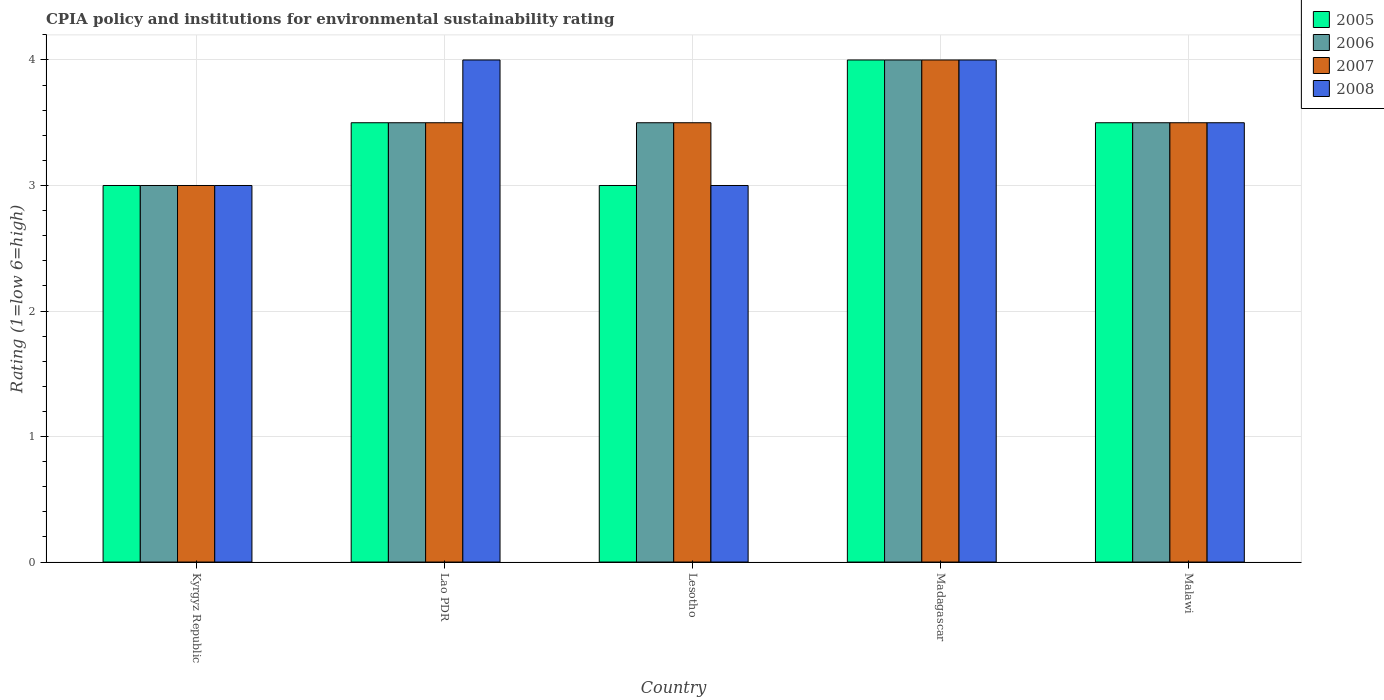How many different coloured bars are there?
Your answer should be compact. 4. How many groups of bars are there?
Your answer should be very brief. 5. Are the number of bars on each tick of the X-axis equal?
Keep it short and to the point. Yes. What is the label of the 1st group of bars from the left?
Your response must be concise. Kyrgyz Republic. Across all countries, what is the minimum CPIA rating in 2005?
Offer a terse response. 3. In which country was the CPIA rating in 2007 maximum?
Offer a terse response. Madagascar. In which country was the CPIA rating in 2007 minimum?
Provide a short and direct response. Kyrgyz Republic. What is the total CPIA rating in 2006 in the graph?
Offer a very short reply. 17.5. Is the difference between the CPIA rating in 2006 in Kyrgyz Republic and Lao PDR greater than the difference between the CPIA rating in 2005 in Kyrgyz Republic and Lao PDR?
Provide a short and direct response. No. In how many countries, is the CPIA rating in 2006 greater than the average CPIA rating in 2006 taken over all countries?
Offer a terse response. 1. Is it the case that in every country, the sum of the CPIA rating in 2006 and CPIA rating in 2008 is greater than the sum of CPIA rating in 2007 and CPIA rating in 2005?
Your answer should be very brief. No. What does the 1st bar from the left in Madagascar represents?
Give a very brief answer. 2005. What does the 1st bar from the right in Kyrgyz Republic represents?
Provide a short and direct response. 2008. Is it the case that in every country, the sum of the CPIA rating in 2007 and CPIA rating in 2008 is greater than the CPIA rating in 2006?
Offer a terse response. Yes. Are the values on the major ticks of Y-axis written in scientific E-notation?
Keep it short and to the point. No. Does the graph contain grids?
Provide a succinct answer. Yes. Where does the legend appear in the graph?
Offer a very short reply. Top right. How are the legend labels stacked?
Your answer should be compact. Vertical. What is the title of the graph?
Offer a very short reply. CPIA policy and institutions for environmental sustainability rating. Does "2012" appear as one of the legend labels in the graph?
Offer a terse response. No. What is the Rating (1=low 6=high) of 2006 in Kyrgyz Republic?
Your answer should be very brief. 3. What is the Rating (1=low 6=high) in 2007 in Kyrgyz Republic?
Your answer should be compact. 3. What is the Rating (1=low 6=high) of 2008 in Lao PDR?
Offer a terse response. 4. What is the Rating (1=low 6=high) in 2005 in Lesotho?
Offer a very short reply. 3. What is the Rating (1=low 6=high) in 2008 in Lesotho?
Offer a terse response. 3. What is the Rating (1=low 6=high) in 2006 in Madagascar?
Offer a terse response. 4. What is the Rating (1=low 6=high) in 2007 in Madagascar?
Your answer should be very brief. 4. What is the Rating (1=low 6=high) of 2008 in Madagascar?
Give a very brief answer. 4. What is the Rating (1=low 6=high) in 2006 in Malawi?
Your response must be concise. 3.5. What is the Rating (1=low 6=high) of 2007 in Malawi?
Your answer should be very brief. 3.5. Across all countries, what is the maximum Rating (1=low 6=high) of 2008?
Your answer should be very brief. 4. Across all countries, what is the minimum Rating (1=low 6=high) of 2006?
Give a very brief answer. 3. Across all countries, what is the minimum Rating (1=low 6=high) of 2008?
Offer a very short reply. 3. What is the total Rating (1=low 6=high) in 2008 in the graph?
Your answer should be very brief. 17.5. What is the difference between the Rating (1=low 6=high) of 2007 in Kyrgyz Republic and that in Lao PDR?
Offer a very short reply. -0.5. What is the difference between the Rating (1=low 6=high) in 2008 in Kyrgyz Republic and that in Lao PDR?
Keep it short and to the point. -1. What is the difference between the Rating (1=low 6=high) in 2005 in Kyrgyz Republic and that in Lesotho?
Offer a terse response. 0. What is the difference between the Rating (1=low 6=high) of 2006 in Kyrgyz Republic and that in Lesotho?
Ensure brevity in your answer.  -0.5. What is the difference between the Rating (1=low 6=high) in 2008 in Kyrgyz Republic and that in Madagascar?
Offer a terse response. -1. What is the difference between the Rating (1=low 6=high) in 2008 in Lao PDR and that in Lesotho?
Ensure brevity in your answer.  1. What is the difference between the Rating (1=low 6=high) in 2006 in Lao PDR and that in Madagascar?
Offer a very short reply. -0.5. What is the difference between the Rating (1=low 6=high) in 2007 in Lao PDR and that in Madagascar?
Provide a short and direct response. -0.5. What is the difference between the Rating (1=low 6=high) of 2008 in Lao PDR and that in Madagascar?
Your answer should be very brief. 0. What is the difference between the Rating (1=low 6=high) in 2005 in Lao PDR and that in Malawi?
Offer a terse response. 0. What is the difference between the Rating (1=low 6=high) of 2006 in Lao PDR and that in Malawi?
Provide a succinct answer. 0. What is the difference between the Rating (1=low 6=high) of 2008 in Lao PDR and that in Malawi?
Make the answer very short. 0.5. What is the difference between the Rating (1=low 6=high) in 2005 in Lesotho and that in Madagascar?
Ensure brevity in your answer.  -1. What is the difference between the Rating (1=low 6=high) of 2006 in Lesotho and that in Madagascar?
Offer a terse response. -0.5. What is the difference between the Rating (1=low 6=high) of 2008 in Lesotho and that in Madagascar?
Give a very brief answer. -1. What is the difference between the Rating (1=low 6=high) of 2007 in Lesotho and that in Malawi?
Give a very brief answer. 0. What is the difference between the Rating (1=low 6=high) in 2005 in Madagascar and that in Malawi?
Keep it short and to the point. 0.5. What is the difference between the Rating (1=low 6=high) in 2005 in Kyrgyz Republic and the Rating (1=low 6=high) in 2006 in Lao PDR?
Provide a short and direct response. -0.5. What is the difference between the Rating (1=low 6=high) of 2005 in Kyrgyz Republic and the Rating (1=low 6=high) of 2007 in Lao PDR?
Your answer should be compact. -0.5. What is the difference between the Rating (1=low 6=high) of 2005 in Kyrgyz Republic and the Rating (1=low 6=high) of 2008 in Lao PDR?
Provide a short and direct response. -1. What is the difference between the Rating (1=low 6=high) of 2006 in Kyrgyz Republic and the Rating (1=low 6=high) of 2007 in Lao PDR?
Ensure brevity in your answer.  -0.5. What is the difference between the Rating (1=low 6=high) in 2007 in Kyrgyz Republic and the Rating (1=low 6=high) in 2008 in Lao PDR?
Keep it short and to the point. -1. What is the difference between the Rating (1=low 6=high) in 2005 in Kyrgyz Republic and the Rating (1=low 6=high) in 2007 in Lesotho?
Provide a succinct answer. -0.5. What is the difference between the Rating (1=low 6=high) in 2005 in Kyrgyz Republic and the Rating (1=low 6=high) in 2008 in Lesotho?
Offer a terse response. 0. What is the difference between the Rating (1=low 6=high) of 2006 in Kyrgyz Republic and the Rating (1=low 6=high) of 2007 in Lesotho?
Make the answer very short. -0.5. What is the difference between the Rating (1=low 6=high) in 2006 in Kyrgyz Republic and the Rating (1=low 6=high) in 2008 in Lesotho?
Offer a very short reply. 0. What is the difference between the Rating (1=low 6=high) of 2007 in Kyrgyz Republic and the Rating (1=low 6=high) of 2008 in Lesotho?
Offer a terse response. 0. What is the difference between the Rating (1=low 6=high) in 2005 in Kyrgyz Republic and the Rating (1=low 6=high) in 2008 in Madagascar?
Offer a very short reply. -1. What is the difference between the Rating (1=low 6=high) in 2006 in Kyrgyz Republic and the Rating (1=low 6=high) in 2007 in Madagascar?
Your response must be concise. -1. What is the difference between the Rating (1=low 6=high) in 2007 in Kyrgyz Republic and the Rating (1=low 6=high) in 2008 in Madagascar?
Make the answer very short. -1. What is the difference between the Rating (1=low 6=high) in 2005 in Kyrgyz Republic and the Rating (1=low 6=high) in 2006 in Malawi?
Your answer should be compact. -0.5. What is the difference between the Rating (1=low 6=high) in 2006 in Kyrgyz Republic and the Rating (1=low 6=high) in 2007 in Malawi?
Offer a terse response. -0.5. What is the difference between the Rating (1=low 6=high) of 2006 in Lao PDR and the Rating (1=low 6=high) of 2007 in Lesotho?
Ensure brevity in your answer.  0. What is the difference between the Rating (1=low 6=high) in 2007 in Lao PDR and the Rating (1=low 6=high) in 2008 in Lesotho?
Offer a very short reply. 0.5. What is the difference between the Rating (1=low 6=high) of 2005 in Lao PDR and the Rating (1=low 6=high) of 2008 in Madagascar?
Ensure brevity in your answer.  -0.5. What is the difference between the Rating (1=low 6=high) in 2007 in Lao PDR and the Rating (1=low 6=high) in 2008 in Madagascar?
Provide a short and direct response. -0.5. What is the difference between the Rating (1=low 6=high) in 2006 in Lao PDR and the Rating (1=low 6=high) in 2007 in Malawi?
Ensure brevity in your answer.  0. What is the difference between the Rating (1=low 6=high) of 2007 in Lao PDR and the Rating (1=low 6=high) of 2008 in Malawi?
Provide a short and direct response. 0. What is the difference between the Rating (1=low 6=high) in 2005 in Lesotho and the Rating (1=low 6=high) in 2006 in Madagascar?
Your answer should be very brief. -1. What is the difference between the Rating (1=low 6=high) of 2005 in Lesotho and the Rating (1=low 6=high) of 2007 in Madagascar?
Your response must be concise. -1. What is the difference between the Rating (1=low 6=high) of 2006 in Lesotho and the Rating (1=low 6=high) of 2007 in Madagascar?
Offer a very short reply. -0.5. What is the difference between the Rating (1=low 6=high) in 2006 in Lesotho and the Rating (1=low 6=high) in 2008 in Madagascar?
Ensure brevity in your answer.  -0.5. What is the difference between the Rating (1=low 6=high) in 2005 in Lesotho and the Rating (1=low 6=high) in 2006 in Malawi?
Ensure brevity in your answer.  -0.5. What is the difference between the Rating (1=low 6=high) in 2005 in Lesotho and the Rating (1=low 6=high) in 2008 in Malawi?
Give a very brief answer. -0.5. What is the difference between the Rating (1=low 6=high) in 2006 in Lesotho and the Rating (1=low 6=high) in 2007 in Malawi?
Give a very brief answer. 0. What is the difference between the Rating (1=low 6=high) in 2007 in Lesotho and the Rating (1=low 6=high) in 2008 in Malawi?
Your response must be concise. 0. What is the difference between the Rating (1=low 6=high) in 2005 in Madagascar and the Rating (1=low 6=high) in 2006 in Malawi?
Keep it short and to the point. 0.5. What is the difference between the Rating (1=low 6=high) of 2005 in Madagascar and the Rating (1=low 6=high) of 2007 in Malawi?
Your response must be concise. 0.5. What is the difference between the Rating (1=low 6=high) in 2005 in Madagascar and the Rating (1=low 6=high) in 2008 in Malawi?
Ensure brevity in your answer.  0.5. What is the difference between the Rating (1=low 6=high) in 2006 in Madagascar and the Rating (1=low 6=high) in 2007 in Malawi?
Your answer should be very brief. 0.5. What is the difference between the Rating (1=low 6=high) of 2006 in Madagascar and the Rating (1=low 6=high) of 2008 in Malawi?
Give a very brief answer. 0.5. What is the average Rating (1=low 6=high) in 2005 per country?
Give a very brief answer. 3.4. What is the average Rating (1=low 6=high) of 2006 per country?
Offer a terse response. 3.5. What is the average Rating (1=low 6=high) in 2007 per country?
Your answer should be very brief. 3.5. What is the difference between the Rating (1=low 6=high) of 2005 and Rating (1=low 6=high) of 2006 in Kyrgyz Republic?
Keep it short and to the point. 0. What is the difference between the Rating (1=low 6=high) of 2005 and Rating (1=low 6=high) of 2007 in Kyrgyz Republic?
Give a very brief answer. 0. What is the difference between the Rating (1=low 6=high) of 2005 and Rating (1=low 6=high) of 2008 in Kyrgyz Republic?
Your response must be concise. 0. What is the difference between the Rating (1=low 6=high) in 2006 and Rating (1=low 6=high) in 2007 in Kyrgyz Republic?
Provide a succinct answer. 0. What is the difference between the Rating (1=low 6=high) of 2007 and Rating (1=low 6=high) of 2008 in Kyrgyz Republic?
Provide a succinct answer. 0. What is the difference between the Rating (1=low 6=high) in 2005 and Rating (1=low 6=high) in 2006 in Lao PDR?
Your answer should be very brief. 0. What is the difference between the Rating (1=low 6=high) of 2005 and Rating (1=low 6=high) of 2007 in Lao PDR?
Offer a very short reply. 0. What is the difference between the Rating (1=low 6=high) in 2005 and Rating (1=low 6=high) in 2008 in Lao PDR?
Your response must be concise. -0.5. What is the difference between the Rating (1=low 6=high) in 2006 and Rating (1=low 6=high) in 2007 in Lao PDR?
Your response must be concise. 0. What is the difference between the Rating (1=low 6=high) of 2005 and Rating (1=low 6=high) of 2007 in Lesotho?
Provide a short and direct response. -0.5. What is the difference between the Rating (1=low 6=high) of 2005 and Rating (1=low 6=high) of 2008 in Lesotho?
Make the answer very short. 0. What is the difference between the Rating (1=low 6=high) in 2006 and Rating (1=low 6=high) in 2007 in Lesotho?
Your answer should be very brief. 0. What is the difference between the Rating (1=low 6=high) in 2005 and Rating (1=low 6=high) in 2007 in Madagascar?
Provide a succinct answer. 0. What is the difference between the Rating (1=low 6=high) of 2006 and Rating (1=low 6=high) of 2007 in Madagascar?
Provide a succinct answer. 0. What is the difference between the Rating (1=low 6=high) of 2005 and Rating (1=low 6=high) of 2006 in Malawi?
Your answer should be compact. 0. What is the difference between the Rating (1=low 6=high) of 2006 and Rating (1=low 6=high) of 2008 in Malawi?
Make the answer very short. 0. What is the ratio of the Rating (1=low 6=high) of 2005 in Kyrgyz Republic to that in Lao PDR?
Ensure brevity in your answer.  0.86. What is the ratio of the Rating (1=low 6=high) in 2008 in Kyrgyz Republic to that in Lao PDR?
Your response must be concise. 0.75. What is the ratio of the Rating (1=low 6=high) of 2005 in Kyrgyz Republic to that in Lesotho?
Your answer should be compact. 1. What is the ratio of the Rating (1=low 6=high) in 2006 in Kyrgyz Republic to that in Lesotho?
Your response must be concise. 0.86. What is the ratio of the Rating (1=low 6=high) of 2008 in Kyrgyz Republic to that in Lesotho?
Give a very brief answer. 1. What is the ratio of the Rating (1=low 6=high) of 2007 in Kyrgyz Republic to that in Madagascar?
Keep it short and to the point. 0.75. What is the ratio of the Rating (1=low 6=high) of 2008 in Kyrgyz Republic to that in Malawi?
Your answer should be very brief. 0.86. What is the ratio of the Rating (1=low 6=high) of 2005 in Lao PDR to that in Lesotho?
Your response must be concise. 1.17. What is the ratio of the Rating (1=low 6=high) of 2006 in Lao PDR to that in Lesotho?
Offer a terse response. 1. What is the ratio of the Rating (1=low 6=high) in 2007 in Lao PDR to that in Lesotho?
Provide a succinct answer. 1. What is the ratio of the Rating (1=low 6=high) of 2008 in Lao PDR to that in Lesotho?
Offer a terse response. 1.33. What is the ratio of the Rating (1=low 6=high) in 2006 in Lao PDR to that in Madagascar?
Provide a succinct answer. 0.88. What is the ratio of the Rating (1=low 6=high) in 2005 in Lao PDR to that in Malawi?
Your response must be concise. 1. What is the ratio of the Rating (1=low 6=high) of 2005 in Lesotho to that in Madagascar?
Make the answer very short. 0.75. What is the ratio of the Rating (1=low 6=high) in 2008 in Lesotho to that in Madagascar?
Your answer should be compact. 0.75. What is the ratio of the Rating (1=low 6=high) of 2007 in Lesotho to that in Malawi?
Your answer should be very brief. 1. What is the ratio of the Rating (1=low 6=high) in 2008 in Lesotho to that in Malawi?
Your answer should be compact. 0.86. What is the ratio of the Rating (1=low 6=high) of 2008 in Madagascar to that in Malawi?
Provide a short and direct response. 1.14. What is the difference between the highest and the lowest Rating (1=low 6=high) in 2005?
Your response must be concise. 1. What is the difference between the highest and the lowest Rating (1=low 6=high) of 2006?
Offer a very short reply. 1. What is the difference between the highest and the lowest Rating (1=low 6=high) in 2007?
Offer a terse response. 1. 